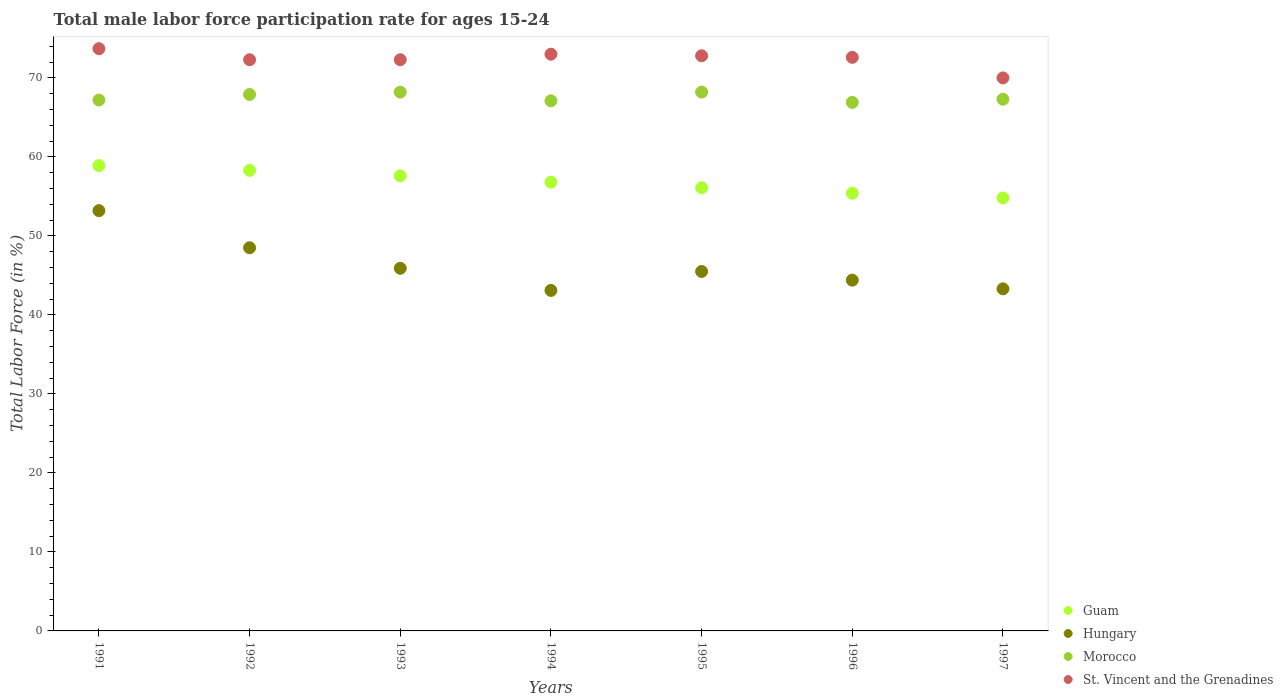How many different coloured dotlines are there?
Your answer should be very brief. 4. Is the number of dotlines equal to the number of legend labels?
Your response must be concise. Yes. What is the male labor force participation rate in St. Vincent and the Grenadines in 1994?
Give a very brief answer. 73. Across all years, what is the maximum male labor force participation rate in St. Vincent and the Grenadines?
Your answer should be compact. 73.7. Across all years, what is the minimum male labor force participation rate in Guam?
Ensure brevity in your answer.  54.8. In which year was the male labor force participation rate in Morocco maximum?
Keep it short and to the point. 1993. In which year was the male labor force participation rate in Morocco minimum?
Your answer should be very brief. 1996. What is the total male labor force participation rate in St. Vincent and the Grenadines in the graph?
Give a very brief answer. 506.7. What is the difference between the male labor force participation rate in Hungary in 1995 and that in 1996?
Keep it short and to the point. 1.1. What is the difference between the male labor force participation rate in Morocco in 1992 and the male labor force participation rate in Guam in 1994?
Keep it short and to the point. 11.1. What is the average male labor force participation rate in Morocco per year?
Offer a terse response. 67.54. In the year 1993, what is the difference between the male labor force participation rate in Guam and male labor force participation rate in St. Vincent and the Grenadines?
Keep it short and to the point. -14.7. What is the ratio of the male labor force participation rate in Morocco in 1992 to that in 1993?
Offer a very short reply. 1. Is the male labor force participation rate in Hungary in 1993 less than that in 1995?
Provide a short and direct response. No. Is the difference between the male labor force participation rate in Guam in 1993 and 1997 greater than the difference between the male labor force participation rate in St. Vincent and the Grenadines in 1993 and 1997?
Ensure brevity in your answer.  Yes. What is the difference between the highest and the second highest male labor force participation rate in Hungary?
Keep it short and to the point. 4.7. What is the difference between the highest and the lowest male labor force participation rate in Morocco?
Your answer should be very brief. 1.3. Is the sum of the male labor force participation rate in Hungary in 1995 and 1997 greater than the maximum male labor force participation rate in Guam across all years?
Offer a terse response. Yes. Is it the case that in every year, the sum of the male labor force participation rate in Guam and male labor force participation rate in St. Vincent and the Grenadines  is greater than the sum of male labor force participation rate in Hungary and male labor force participation rate in Morocco?
Keep it short and to the point. No. Is it the case that in every year, the sum of the male labor force participation rate in St. Vincent and the Grenadines and male labor force participation rate in Guam  is greater than the male labor force participation rate in Hungary?
Give a very brief answer. Yes. Is the male labor force participation rate in Guam strictly greater than the male labor force participation rate in Hungary over the years?
Your answer should be compact. Yes. Is the male labor force participation rate in Guam strictly less than the male labor force participation rate in Hungary over the years?
Ensure brevity in your answer.  No. How many dotlines are there?
Give a very brief answer. 4. How many years are there in the graph?
Ensure brevity in your answer.  7. Does the graph contain any zero values?
Provide a succinct answer. No. Does the graph contain grids?
Your answer should be very brief. No. Where does the legend appear in the graph?
Provide a short and direct response. Bottom right. How many legend labels are there?
Offer a very short reply. 4. What is the title of the graph?
Your answer should be compact. Total male labor force participation rate for ages 15-24. Does "Mauritius" appear as one of the legend labels in the graph?
Your answer should be very brief. No. What is the label or title of the Y-axis?
Keep it short and to the point. Total Labor Force (in %). What is the Total Labor Force (in %) of Guam in 1991?
Your response must be concise. 58.9. What is the Total Labor Force (in %) of Hungary in 1991?
Give a very brief answer. 53.2. What is the Total Labor Force (in %) of Morocco in 1991?
Ensure brevity in your answer.  67.2. What is the Total Labor Force (in %) of St. Vincent and the Grenadines in 1991?
Your response must be concise. 73.7. What is the Total Labor Force (in %) of Guam in 1992?
Your response must be concise. 58.3. What is the Total Labor Force (in %) in Hungary in 1992?
Provide a short and direct response. 48.5. What is the Total Labor Force (in %) of Morocco in 1992?
Provide a short and direct response. 67.9. What is the Total Labor Force (in %) in St. Vincent and the Grenadines in 1992?
Your response must be concise. 72.3. What is the Total Labor Force (in %) in Guam in 1993?
Keep it short and to the point. 57.6. What is the Total Labor Force (in %) in Hungary in 1993?
Your response must be concise. 45.9. What is the Total Labor Force (in %) in Morocco in 1993?
Your answer should be compact. 68.2. What is the Total Labor Force (in %) of St. Vincent and the Grenadines in 1993?
Provide a short and direct response. 72.3. What is the Total Labor Force (in %) in Guam in 1994?
Make the answer very short. 56.8. What is the Total Labor Force (in %) of Hungary in 1994?
Keep it short and to the point. 43.1. What is the Total Labor Force (in %) in Morocco in 1994?
Your response must be concise. 67.1. What is the Total Labor Force (in %) in St. Vincent and the Grenadines in 1994?
Offer a very short reply. 73. What is the Total Labor Force (in %) of Guam in 1995?
Your answer should be very brief. 56.1. What is the Total Labor Force (in %) of Hungary in 1995?
Your answer should be compact. 45.5. What is the Total Labor Force (in %) in Morocco in 1995?
Keep it short and to the point. 68.2. What is the Total Labor Force (in %) of St. Vincent and the Grenadines in 1995?
Give a very brief answer. 72.8. What is the Total Labor Force (in %) in Guam in 1996?
Keep it short and to the point. 55.4. What is the Total Labor Force (in %) in Hungary in 1996?
Your answer should be very brief. 44.4. What is the Total Labor Force (in %) in Morocco in 1996?
Keep it short and to the point. 66.9. What is the Total Labor Force (in %) of St. Vincent and the Grenadines in 1996?
Your response must be concise. 72.6. What is the Total Labor Force (in %) of Guam in 1997?
Offer a very short reply. 54.8. What is the Total Labor Force (in %) in Hungary in 1997?
Provide a short and direct response. 43.3. What is the Total Labor Force (in %) in Morocco in 1997?
Your answer should be compact. 67.3. What is the Total Labor Force (in %) of St. Vincent and the Grenadines in 1997?
Offer a terse response. 70. Across all years, what is the maximum Total Labor Force (in %) in Guam?
Your answer should be very brief. 58.9. Across all years, what is the maximum Total Labor Force (in %) in Hungary?
Your response must be concise. 53.2. Across all years, what is the maximum Total Labor Force (in %) in Morocco?
Ensure brevity in your answer.  68.2. Across all years, what is the maximum Total Labor Force (in %) in St. Vincent and the Grenadines?
Offer a very short reply. 73.7. Across all years, what is the minimum Total Labor Force (in %) in Guam?
Your answer should be compact. 54.8. Across all years, what is the minimum Total Labor Force (in %) in Hungary?
Offer a very short reply. 43.1. Across all years, what is the minimum Total Labor Force (in %) of Morocco?
Keep it short and to the point. 66.9. What is the total Total Labor Force (in %) in Guam in the graph?
Your answer should be compact. 397.9. What is the total Total Labor Force (in %) of Hungary in the graph?
Your answer should be compact. 323.9. What is the total Total Labor Force (in %) of Morocco in the graph?
Keep it short and to the point. 472.8. What is the total Total Labor Force (in %) in St. Vincent and the Grenadines in the graph?
Offer a terse response. 506.7. What is the difference between the Total Labor Force (in %) of Morocco in 1991 and that in 1992?
Provide a succinct answer. -0.7. What is the difference between the Total Labor Force (in %) in St. Vincent and the Grenadines in 1991 and that in 1992?
Provide a succinct answer. 1.4. What is the difference between the Total Labor Force (in %) of Hungary in 1991 and that in 1993?
Ensure brevity in your answer.  7.3. What is the difference between the Total Labor Force (in %) in St. Vincent and the Grenadines in 1991 and that in 1993?
Offer a very short reply. 1.4. What is the difference between the Total Labor Force (in %) of Guam in 1991 and that in 1994?
Offer a terse response. 2.1. What is the difference between the Total Labor Force (in %) of St. Vincent and the Grenadines in 1991 and that in 1994?
Keep it short and to the point. 0.7. What is the difference between the Total Labor Force (in %) in Guam in 1991 and that in 1995?
Offer a terse response. 2.8. What is the difference between the Total Labor Force (in %) in Hungary in 1991 and that in 1995?
Give a very brief answer. 7.7. What is the difference between the Total Labor Force (in %) of Morocco in 1991 and that in 1995?
Ensure brevity in your answer.  -1. What is the difference between the Total Labor Force (in %) of Guam in 1991 and that in 1996?
Provide a short and direct response. 3.5. What is the difference between the Total Labor Force (in %) in Guam in 1991 and that in 1997?
Give a very brief answer. 4.1. What is the difference between the Total Labor Force (in %) in Morocco in 1991 and that in 1997?
Your response must be concise. -0.1. What is the difference between the Total Labor Force (in %) in St. Vincent and the Grenadines in 1991 and that in 1997?
Provide a succinct answer. 3.7. What is the difference between the Total Labor Force (in %) of Guam in 1992 and that in 1993?
Offer a very short reply. 0.7. What is the difference between the Total Labor Force (in %) of Guam in 1992 and that in 1994?
Offer a very short reply. 1.5. What is the difference between the Total Labor Force (in %) of Hungary in 1992 and that in 1994?
Your response must be concise. 5.4. What is the difference between the Total Labor Force (in %) of St. Vincent and the Grenadines in 1992 and that in 1994?
Provide a succinct answer. -0.7. What is the difference between the Total Labor Force (in %) in Guam in 1992 and that in 1995?
Provide a short and direct response. 2.2. What is the difference between the Total Labor Force (in %) of Morocco in 1992 and that in 1995?
Your response must be concise. -0.3. What is the difference between the Total Labor Force (in %) of St. Vincent and the Grenadines in 1992 and that in 1995?
Make the answer very short. -0.5. What is the difference between the Total Labor Force (in %) in Hungary in 1992 and that in 1996?
Your answer should be very brief. 4.1. What is the difference between the Total Labor Force (in %) of St. Vincent and the Grenadines in 1992 and that in 1996?
Offer a very short reply. -0.3. What is the difference between the Total Labor Force (in %) in Morocco in 1992 and that in 1997?
Your answer should be compact. 0.6. What is the difference between the Total Labor Force (in %) of Hungary in 1993 and that in 1995?
Your answer should be compact. 0.4. What is the difference between the Total Labor Force (in %) of Morocco in 1993 and that in 1995?
Ensure brevity in your answer.  0. What is the difference between the Total Labor Force (in %) of St. Vincent and the Grenadines in 1993 and that in 1995?
Provide a short and direct response. -0.5. What is the difference between the Total Labor Force (in %) in Morocco in 1993 and that in 1996?
Provide a short and direct response. 1.3. What is the difference between the Total Labor Force (in %) in St. Vincent and the Grenadines in 1993 and that in 1996?
Provide a succinct answer. -0.3. What is the difference between the Total Labor Force (in %) of Guam in 1993 and that in 1997?
Your answer should be compact. 2.8. What is the difference between the Total Labor Force (in %) in Morocco in 1993 and that in 1997?
Offer a terse response. 0.9. What is the difference between the Total Labor Force (in %) of St. Vincent and the Grenadines in 1993 and that in 1997?
Make the answer very short. 2.3. What is the difference between the Total Labor Force (in %) of Guam in 1994 and that in 1995?
Offer a very short reply. 0.7. What is the difference between the Total Labor Force (in %) in Hungary in 1994 and that in 1995?
Offer a very short reply. -2.4. What is the difference between the Total Labor Force (in %) in Morocco in 1994 and that in 1995?
Give a very brief answer. -1.1. What is the difference between the Total Labor Force (in %) in St. Vincent and the Grenadines in 1994 and that in 1995?
Offer a terse response. 0.2. What is the difference between the Total Labor Force (in %) of Morocco in 1994 and that in 1996?
Your response must be concise. 0.2. What is the difference between the Total Labor Force (in %) in St. Vincent and the Grenadines in 1994 and that in 1996?
Ensure brevity in your answer.  0.4. What is the difference between the Total Labor Force (in %) in Hungary in 1994 and that in 1997?
Your response must be concise. -0.2. What is the difference between the Total Labor Force (in %) in Guam in 1995 and that in 1997?
Your response must be concise. 1.3. What is the difference between the Total Labor Force (in %) in Hungary in 1995 and that in 1997?
Your response must be concise. 2.2. What is the difference between the Total Labor Force (in %) in Guam in 1996 and that in 1997?
Provide a succinct answer. 0.6. What is the difference between the Total Labor Force (in %) of Guam in 1991 and the Total Labor Force (in %) of St. Vincent and the Grenadines in 1992?
Provide a short and direct response. -13.4. What is the difference between the Total Labor Force (in %) of Hungary in 1991 and the Total Labor Force (in %) of Morocco in 1992?
Offer a very short reply. -14.7. What is the difference between the Total Labor Force (in %) in Hungary in 1991 and the Total Labor Force (in %) in St. Vincent and the Grenadines in 1992?
Your answer should be compact. -19.1. What is the difference between the Total Labor Force (in %) in Morocco in 1991 and the Total Labor Force (in %) in St. Vincent and the Grenadines in 1992?
Keep it short and to the point. -5.1. What is the difference between the Total Labor Force (in %) in Guam in 1991 and the Total Labor Force (in %) in Hungary in 1993?
Provide a succinct answer. 13. What is the difference between the Total Labor Force (in %) of Hungary in 1991 and the Total Labor Force (in %) of Morocco in 1993?
Give a very brief answer. -15. What is the difference between the Total Labor Force (in %) in Hungary in 1991 and the Total Labor Force (in %) in St. Vincent and the Grenadines in 1993?
Offer a very short reply. -19.1. What is the difference between the Total Labor Force (in %) of Guam in 1991 and the Total Labor Force (in %) of Hungary in 1994?
Offer a terse response. 15.8. What is the difference between the Total Labor Force (in %) in Guam in 1991 and the Total Labor Force (in %) in St. Vincent and the Grenadines in 1994?
Your answer should be compact. -14.1. What is the difference between the Total Labor Force (in %) of Hungary in 1991 and the Total Labor Force (in %) of St. Vincent and the Grenadines in 1994?
Make the answer very short. -19.8. What is the difference between the Total Labor Force (in %) in Guam in 1991 and the Total Labor Force (in %) in Hungary in 1995?
Your answer should be compact. 13.4. What is the difference between the Total Labor Force (in %) of Hungary in 1991 and the Total Labor Force (in %) of Morocco in 1995?
Provide a short and direct response. -15. What is the difference between the Total Labor Force (in %) in Hungary in 1991 and the Total Labor Force (in %) in St. Vincent and the Grenadines in 1995?
Your answer should be compact. -19.6. What is the difference between the Total Labor Force (in %) in Guam in 1991 and the Total Labor Force (in %) in Hungary in 1996?
Your answer should be very brief. 14.5. What is the difference between the Total Labor Force (in %) in Guam in 1991 and the Total Labor Force (in %) in St. Vincent and the Grenadines in 1996?
Ensure brevity in your answer.  -13.7. What is the difference between the Total Labor Force (in %) in Hungary in 1991 and the Total Labor Force (in %) in Morocco in 1996?
Give a very brief answer. -13.7. What is the difference between the Total Labor Force (in %) in Hungary in 1991 and the Total Labor Force (in %) in St. Vincent and the Grenadines in 1996?
Your response must be concise. -19.4. What is the difference between the Total Labor Force (in %) of Hungary in 1991 and the Total Labor Force (in %) of Morocco in 1997?
Offer a very short reply. -14.1. What is the difference between the Total Labor Force (in %) of Hungary in 1991 and the Total Labor Force (in %) of St. Vincent and the Grenadines in 1997?
Provide a short and direct response. -16.8. What is the difference between the Total Labor Force (in %) of Morocco in 1991 and the Total Labor Force (in %) of St. Vincent and the Grenadines in 1997?
Keep it short and to the point. -2.8. What is the difference between the Total Labor Force (in %) in Guam in 1992 and the Total Labor Force (in %) in Hungary in 1993?
Give a very brief answer. 12.4. What is the difference between the Total Labor Force (in %) of Guam in 1992 and the Total Labor Force (in %) of Morocco in 1993?
Your answer should be compact. -9.9. What is the difference between the Total Labor Force (in %) of Guam in 1992 and the Total Labor Force (in %) of St. Vincent and the Grenadines in 1993?
Provide a short and direct response. -14. What is the difference between the Total Labor Force (in %) of Hungary in 1992 and the Total Labor Force (in %) of Morocco in 1993?
Keep it short and to the point. -19.7. What is the difference between the Total Labor Force (in %) in Hungary in 1992 and the Total Labor Force (in %) in St. Vincent and the Grenadines in 1993?
Offer a terse response. -23.8. What is the difference between the Total Labor Force (in %) of Guam in 1992 and the Total Labor Force (in %) of Morocco in 1994?
Offer a very short reply. -8.8. What is the difference between the Total Labor Force (in %) of Guam in 1992 and the Total Labor Force (in %) of St. Vincent and the Grenadines in 1994?
Offer a terse response. -14.7. What is the difference between the Total Labor Force (in %) in Hungary in 1992 and the Total Labor Force (in %) in Morocco in 1994?
Give a very brief answer. -18.6. What is the difference between the Total Labor Force (in %) of Hungary in 1992 and the Total Labor Force (in %) of St. Vincent and the Grenadines in 1994?
Your answer should be compact. -24.5. What is the difference between the Total Labor Force (in %) in Morocco in 1992 and the Total Labor Force (in %) in St. Vincent and the Grenadines in 1994?
Your answer should be very brief. -5.1. What is the difference between the Total Labor Force (in %) of Guam in 1992 and the Total Labor Force (in %) of Hungary in 1995?
Offer a terse response. 12.8. What is the difference between the Total Labor Force (in %) in Guam in 1992 and the Total Labor Force (in %) in Morocco in 1995?
Offer a very short reply. -9.9. What is the difference between the Total Labor Force (in %) in Hungary in 1992 and the Total Labor Force (in %) in Morocco in 1995?
Make the answer very short. -19.7. What is the difference between the Total Labor Force (in %) in Hungary in 1992 and the Total Labor Force (in %) in St. Vincent and the Grenadines in 1995?
Provide a short and direct response. -24.3. What is the difference between the Total Labor Force (in %) of Guam in 1992 and the Total Labor Force (in %) of Morocco in 1996?
Offer a terse response. -8.6. What is the difference between the Total Labor Force (in %) in Guam in 1992 and the Total Labor Force (in %) in St. Vincent and the Grenadines in 1996?
Ensure brevity in your answer.  -14.3. What is the difference between the Total Labor Force (in %) in Hungary in 1992 and the Total Labor Force (in %) in Morocco in 1996?
Offer a terse response. -18.4. What is the difference between the Total Labor Force (in %) of Hungary in 1992 and the Total Labor Force (in %) of St. Vincent and the Grenadines in 1996?
Your response must be concise. -24.1. What is the difference between the Total Labor Force (in %) in Morocco in 1992 and the Total Labor Force (in %) in St. Vincent and the Grenadines in 1996?
Your response must be concise. -4.7. What is the difference between the Total Labor Force (in %) in Hungary in 1992 and the Total Labor Force (in %) in Morocco in 1997?
Provide a succinct answer. -18.8. What is the difference between the Total Labor Force (in %) in Hungary in 1992 and the Total Labor Force (in %) in St. Vincent and the Grenadines in 1997?
Provide a short and direct response. -21.5. What is the difference between the Total Labor Force (in %) in Morocco in 1992 and the Total Labor Force (in %) in St. Vincent and the Grenadines in 1997?
Your answer should be compact. -2.1. What is the difference between the Total Labor Force (in %) in Guam in 1993 and the Total Labor Force (in %) in St. Vincent and the Grenadines in 1994?
Make the answer very short. -15.4. What is the difference between the Total Labor Force (in %) in Hungary in 1993 and the Total Labor Force (in %) in Morocco in 1994?
Give a very brief answer. -21.2. What is the difference between the Total Labor Force (in %) of Hungary in 1993 and the Total Labor Force (in %) of St. Vincent and the Grenadines in 1994?
Offer a terse response. -27.1. What is the difference between the Total Labor Force (in %) of Morocco in 1993 and the Total Labor Force (in %) of St. Vincent and the Grenadines in 1994?
Provide a succinct answer. -4.8. What is the difference between the Total Labor Force (in %) of Guam in 1993 and the Total Labor Force (in %) of Hungary in 1995?
Make the answer very short. 12.1. What is the difference between the Total Labor Force (in %) of Guam in 1993 and the Total Labor Force (in %) of Morocco in 1995?
Offer a very short reply. -10.6. What is the difference between the Total Labor Force (in %) in Guam in 1993 and the Total Labor Force (in %) in St. Vincent and the Grenadines in 1995?
Make the answer very short. -15.2. What is the difference between the Total Labor Force (in %) in Hungary in 1993 and the Total Labor Force (in %) in Morocco in 1995?
Offer a very short reply. -22.3. What is the difference between the Total Labor Force (in %) of Hungary in 1993 and the Total Labor Force (in %) of St. Vincent and the Grenadines in 1995?
Keep it short and to the point. -26.9. What is the difference between the Total Labor Force (in %) of Guam in 1993 and the Total Labor Force (in %) of Hungary in 1996?
Ensure brevity in your answer.  13.2. What is the difference between the Total Labor Force (in %) in Guam in 1993 and the Total Labor Force (in %) in Morocco in 1996?
Keep it short and to the point. -9.3. What is the difference between the Total Labor Force (in %) of Hungary in 1993 and the Total Labor Force (in %) of St. Vincent and the Grenadines in 1996?
Give a very brief answer. -26.7. What is the difference between the Total Labor Force (in %) of Morocco in 1993 and the Total Labor Force (in %) of St. Vincent and the Grenadines in 1996?
Give a very brief answer. -4.4. What is the difference between the Total Labor Force (in %) of Guam in 1993 and the Total Labor Force (in %) of Hungary in 1997?
Make the answer very short. 14.3. What is the difference between the Total Labor Force (in %) of Guam in 1993 and the Total Labor Force (in %) of Morocco in 1997?
Keep it short and to the point. -9.7. What is the difference between the Total Labor Force (in %) of Hungary in 1993 and the Total Labor Force (in %) of Morocco in 1997?
Give a very brief answer. -21.4. What is the difference between the Total Labor Force (in %) in Hungary in 1993 and the Total Labor Force (in %) in St. Vincent and the Grenadines in 1997?
Keep it short and to the point. -24.1. What is the difference between the Total Labor Force (in %) in Morocco in 1993 and the Total Labor Force (in %) in St. Vincent and the Grenadines in 1997?
Make the answer very short. -1.8. What is the difference between the Total Labor Force (in %) in Hungary in 1994 and the Total Labor Force (in %) in Morocco in 1995?
Keep it short and to the point. -25.1. What is the difference between the Total Labor Force (in %) in Hungary in 1994 and the Total Labor Force (in %) in St. Vincent and the Grenadines in 1995?
Your answer should be very brief. -29.7. What is the difference between the Total Labor Force (in %) in Guam in 1994 and the Total Labor Force (in %) in Hungary in 1996?
Make the answer very short. 12.4. What is the difference between the Total Labor Force (in %) in Guam in 1994 and the Total Labor Force (in %) in Morocco in 1996?
Provide a short and direct response. -10.1. What is the difference between the Total Labor Force (in %) of Guam in 1994 and the Total Labor Force (in %) of St. Vincent and the Grenadines in 1996?
Provide a short and direct response. -15.8. What is the difference between the Total Labor Force (in %) in Hungary in 1994 and the Total Labor Force (in %) in Morocco in 1996?
Offer a terse response. -23.8. What is the difference between the Total Labor Force (in %) of Hungary in 1994 and the Total Labor Force (in %) of St. Vincent and the Grenadines in 1996?
Provide a succinct answer. -29.5. What is the difference between the Total Labor Force (in %) of Guam in 1994 and the Total Labor Force (in %) of Hungary in 1997?
Offer a very short reply. 13.5. What is the difference between the Total Labor Force (in %) in Hungary in 1994 and the Total Labor Force (in %) in Morocco in 1997?
Your answer should be compact. -24.2. What is the difference between the Total Labor Force (in %) in Hungary in 1994 and the Total Labor Force (in %) in St. Vincent and the Grenadines in 1997?
Your response must be concise. -26.9. What is the difference between the Total Labor Force (in %) in Morocco in 1994 and the Total Labor Force (in %) in St. Vincent and the Grenadines in 1997?
Ensure brevity in your answer.  -2.9. What is the difference between the Total Labor Force (in %) of Guam in 1995 and the Total Labor Force (in %) of Hungary in 1996?
Your answer should be very brief. 11.7. What is the difference between the Total Labor Force (in %) of Guam in 1995 and the Total Labor Force (in %) of Morocco in 1996?
Give a very brief answer. -10.8. What is the difference between the Total Labor Force (in %) of Guam in 1995 and the Total Labor Force (in %) of St. Vincent and the Grenadines in 1996?
Give a very brief answer. -16.5. What is the difference between the Total Labor Force (in %) in Hungary in 1995 and the Total Labor Force (in %) in Morocco in 1996?
Your answer should be very brief. -21.4. What is the difference between the Total Labor Force (in %) in Hungary in 1995 and the Total Labor Force (in %) in St. Vincent and the Grenadines in 1996?
Ensure brevity in your answer.  -27.1. What is the difference between the Total Labor Force (in %) of Guam in 1995 and the Total Labor Force (in %) of Hungary in 1997?
Make the answer very short. 12.8. What is the difference between the Total Labor Force (in %) of Guam in 1995 and the Total Labor Force (in %) of St. Vincent and the Grenadines in 1997?
Your response must be concise. -13.9. What is the difference between the Total Labor Force (in %) of Hungary in 1995 and the Total Labor Force (in %) of Morocco in 1997?
Keep it short and to the point. -21.8. What is the difference between the Total Labor Force (in %) in Hungary in 1995 and the Total Labor Force (in %) in St. Vincent and the Grenadines in 1997?
Your answer should be very brief. -24.5. What is the difference between the Total Labor Force (in %) of Guam in 1996 and the Total Labor Force (in %) of Hungary in 1997?
Offer a terse response. 12.1. What is the difference between the Total Labor Force (in %) in Guam in 1996 and the Total Labor Force (in %) in Morocco in 1997?
Your response must be concise. -11.9. What is the difference between the Total Labor Force (in %) in Guam in 1996 and the Total Labor Force (in %) in St. Vincent and the Grenadines in 1997?
Provide a short and direct response. -14.6. What is the difference between the Total Labor Force (in %) in Hungary in 1996 and the Total Labor Force (in %) in Morocco in 1997?
Provide a succinct answer. -22.9. What is the difference between the Total Labor Force (in %) in Hungary in 1996 and the Total Labor Force (in %) in St. Vincent and the Grenadines in 1997?
Your answer should be compact. -25.6. What is the difference between the Total Labor Force (in %) of Morocco in 1996 and the Total Labor Force (in %) of St. Vincent and the Grenadines in 1997?
Provide a succinct answer. -3.1. What is the average Total Labor Force (in %) in Guam per year?
Make the answer very short. 56.84. What is the average Total Labor Force (in %) in Hungary per year?
Offer a very short reply. 46.27. What is the average Total Labor Force (in %) in Morocco per year?
Provide a succinct answer. 67.54. What is the average Total Labor Force (in %) in St. Vincent and the Grenadines per year?
Keep it short and to the point. 72.39. In the year 1991, what is the difference between the Total Labor Force (in %) of Guam and Total Labor Force (in %) of Hungary?
Keep it short and to the point. 5.7. In the year 1991, what is the difference between the Total Labor Force (in %) of Guam and Total Labor Force (in %) of Morocco?
Your response must be concise. -8.3. In the year 1991, what is the difference between the Total Labor Force (in %) in Guam and Total Labor Force (in %) in St. Vincent and the Grenadines?
Provide a short and direct response. -14.8. In the year 1991, what is the difference between the Total Labor Force (in %) of Hungary and Total Labor Force (in %) of St. Vincent and the Grenadines?
Ensure brevity in your answer.  -20.5. In the year 1991, what is the difference between the Total Labor Force (in %) of Morocco and Total Labor Force (in %) of St. Vincent and the Grenadines?
Your answer should be compact. -6.5. In the year 1992, what is the difference between the Total Labor Force (in %) of Guam and Total Labor Force (in %) of St. Vincent and the Grenadines?
Make the answer very short. -14. In the year 1992, what is the difference between the Total Labor Force (in %) of Hungary and Total Labor Force (in %) of Morocco?
Your response must be concise. -19.4. In the year 1992, what is the difference between the Total Labor Force (in %) in Hungary and Total Labor Force (in %) in St. Vincent and the Grenadines?
Give a very brief answer. -23.8. In the year 1993, what is the difference between the Total Labor Force (in %) of Guam and Total Labor Force (in %) of Hungary?
Offer a very short reply. 11.7. In the year 1993, what is the difference between the Total Labor Force (in %) of Guam and Total Labor Force (in %) of St. Vincent and the Grenadines?
Offer a very short reply. -14.7. In the year 1993, what is the difference between the Total Labor Force (in %) of Hungary and Total Labor Force (in %) of Morocco?
Offer a very short reply. -22.3. In the year 1993, what is the difference between the Total Labor Force (in %) of Hungary and Total Labor Force (in %) of St. Vincent and the Grenadines?
Provide a succinct answer. -26.4. In the year 1993, what is the difference between the Total Labor Force (in %) in Morocco and Total Labor Force (in %) in St. Vincent and the Grenadines?
Provide a short and direct response. -4.1. In the year 1994, what is the difference between the Total Labor Force (in %) of Guam and Total Labor Force (in %) of Hungary?
Your response must be concise. 13.7. In the year 1994, what is the difference between the Total Labor Force (in %) in Guam and Total Labor Force (in %) in Morocco?
Your response must be concise. -10.3. In the year 1994, what is the difference between the Total Labor Force (in %) in Guam and Total Labor Force (in %) in St. Vincent and the Grenadines?
Provide a succinct answer. -16.2. In the year 1994, what is the difference between the Total Labor Force (in %) of Hungary and Total Labor Force (in %) of St. Vincent and the Grenadines?
Make the answer very short. -29.9. In the year 1995, what is the difference between the Total Labor Force (in %) of Guam and Total Labor Force (in %) of Morocco?
Offer a terse response. -12.1. In the year 1995, what is the difference between the Total Labor Force (in %) in Guam and Total Labor Force (in %) in St. Vincent and the Grenadines?
Make the answer very short. -16.7. In the year 1995, what is the difference between the Total Labor Force (in %) in Hungary and Total Labor Force (in %) in Morocco?
Provide a short and direct response. -22.7. In the year 1995, what is the difference between the Total Labor Force (in %) of Hungary and Total Labor Force (in %) of St. Vincent and the Grenadines?
Provide a short and direct response. -27.3. In the year 1995, what is the difference between the Total Labor Force (in %) in Morocco and Total Labor Force (in %) in St. Vincent and the Grenadines?
Your response must be concise. -4.6. In the year 1996, what is the difference between the Total Labor Force (in %) in Guam and Total Labor Force (in %) in Hungary?
Keep it short and to the point. 11. In the year 1996, what is the difference between the Total Labor Force (in %) of Guam and Total Labor Force (in %) of St. Vincent and the Grenadines?
Provide a succinct answer. -17.2. In the year 1996, what is the difference between the Total Labor Force (in %) of Hungary and Total Labor Force (in %) of Morocco?
Offer a terse response. -22.5. In the year 1996, what is the difference between the Total Labor Force (in %) of Hungary and Total Labor Force (in %) of St. Vincent and the Grenadines?
Offer a very short reply. -28.2. In the year 1997, what is the difference between the Total Labor Force (in %) of Guam and Total Labor Force (in %) of Morocco?
Offer a terse response. -12.5. In the year 1997, what is the difference between the Total Labor Force (in %) of Guam and Total Labor Force (in %) of St. Vincent and the Grenadines?
Keep it short and to the point. -15.2. In the year 1997, what is the difference between the Total Labor Force (in %) in Hungary and Total Labor Force (in %) in St. Vincent and the Grenadines?
Your answer should be very brief. -26.7. In the year 1997, what is the difference between the Total Labor Force (in %) in Morocco and Total Labor Force (in %) in St. Vincent and the Grenadines?
Give a very brief answer. -2.7. What is the ratio of the Total Labor Force (in %) of Guam in 1991 to that in 1992?
Ensure brevity in your answer.  1.01. What is the ratio of the Total Labor Force (in %) of Hungary in 1991 to that in 1992?
Keep it short and to the point. 1.1. What is the ratio of the Total Labor Force (in %) in Morocco in 1991 to that in 1992?
Your answer should be very brief. 0.99. What is the ratio of the Total Labor Force (in %) in St. Vincent and the Grenadines in 1991 to that in 1992?
Provide a short and direct response. 1.02. What is the ratio of the Total Labor Force (in %) of Guam in 1991 to that in 1993?
Your response must be concise. 1.02. What is the ratio of the Total Labor Force (in %) of Hungary in 1991 to that in 1993?
Your answer should be compact. 1.16. What is the ratio of the Total Labor Force (in %) in St. Vincent and the Grenadines in 1991 to that in 1993?
Offer a terse response. 1.02. What is the ratio of the Total Labor Force (in %) in Guam in 1991 to that in 1994?
Offer a terse response. 1.04. What is the ratio of the Total Labor Force (in %) of Hungary in 1991 to that in 1994?
Offer a terse response. 1.23. What is the ratio of the Total Labor Force (in %) in Morocco in 1991 to that in 1994?
Ensure brevity in your answer.  1. What is the ratio of the Total Labor Force (in %) in St. Vincent and the Grenadines in 1991 to that in 1994?
Make the answer very short. 1.01. What is the ratio of the Total Labor Force (in %) of Guam in 1991 to that in 1995?
Give a very brief answer. 1.05. What is the ratio of the Total Labor Force (in %) in Hungary in 1991 to that in 1995?
Your answer should be compact. 1.17. What is the ratio of the Total Labor Force (in %) in St. Vincent and the Grenadines in 1991 to that in 1995?
Make the answer very short. 1.01. What is the ratio of the Total Labor Force (in %) in Guam in 1991 to that in 1996?
Provide a succinct answer. 1.06. What is the ratio of the Total Labor Force (in %) in Hungary in 1991 to that in 1996?
Give a very brief answer. 1.2. What is the ratio of the Total Labor Force (in %) in St. Vincent and the Grenadines in 1991 to that in 1996?
Offer a very short reply. 1.02. What is the ratio of the Total Labor Force (in %) of Guam in 1991 to that in 1997?
Your answer should be compact. 1.07. What is the ratio of the Total Labor Force (in %) of Hungary in 1991 to that in 1997?
Give a very brief answer. 1.23. What is the ratio of the Total Labor Force (in %) in St. Vincent and the Grenadines in 1991 to that in 1997?
Your response must be concise. 1.05. What is the ratio of the Total Labor Force (in %) of Guam in 1992 to that in 1993?
Offer a very short reply. 1.01. What is the ratio of the Total Labor Force (in %) of Hungary in 1992 to that in 1993?
Offer a terse response. 1.06. What is the ratio of the Total Labor Force (in %) of Guam in 1992 to that in 1994?
Provide a short and direct response. 1.03. What is the ratio of the Total Labor Force (in %) of Hungary in 1992 to that in 1994?
Offer a very short reply. 1.13. What is the ratio of the Total Labor Force (in %) in Morocco in 1992 to that in 1994?
Provide a succinct answer. 1.01. What is the ratio of the Total Labor Force (in %) of St. Vincent and the Grenadines in 1992 to that in 1994?
Keep it short and to the point. 0.99. What is the ratio of the Total Labor Force (in %) in Guam in 1992 to that in 1995?
Your answer should be very brief. 1.04. What is the ratio of the Total Labor Force (in %) of Hungary in 1992 to that in 1995?
Your response must be concise. 1.07. What is the ratio of the Total Labor Force (in %) in St. Vincent and the Grenadines in 1992 to that in 1995?
Provide a succinct answer. 0.99. What is the ratio of the Total Labor Force (in %) in Guam in 1992 to that in 1996?
Keep it short and to the point. 1.05. What is the ratio of the Total Labor Force (in %) of Hungary in 1992 to that in 1996?
Your answer should be compact. 1.09. What is the ratio of the Total Labor Force (in %) in Morocco in 1992 to that in 1996?
Provide a short and direct response. 1.01. What is the ratio of the Total Labor Force (in %) in Guam in 1992 to that in 1997?
Offer a very short reply. 1.06. What is the ratio of the Total Labor Force (in %) in Hungary in 1992 to that in 1997?
Provide a short and direct response. 1.12. What is the ratio of the Total Labor Force (in %) in Morocco in 1992 to that in 1997?
Provide a succinct answer. 1.01. What is the ratio of the Total Labor Force (in %) in St. Vincent and the Grenadines in 1992 to that in 1997?
Your answer should be very brief. 1.03. What is the ratio of the Total Labor Force (in %) of Guam in 1993 to that in 1994?
Make the answer very short. 1.01. What is the ratio of the Total Labor Force (in %) in Hungary in 1993 to that in 1994?
Ensure brevity in your answer.  1.06. What is the ratio of the Total Labor Force (in %) of Morocco in 1993 to that in 1994?
Your answer should be very brief. 1.02. What is the ratio of the Total Labor Force (in %) of St. Vincent and the Grenadines in 1993 to that in 1994?
Your answer should be compact. 0.99. What is the ratio of the Total Labor Force (in %) in Guam in 1993 to that in 1995?
Offer a terse response. 1.03. What is the ratio of the Total Labor Force (in %) of Hungary in 1993 to that in 1995?
Your answer should be compact. 1.01. What is the ratio of the Total Labor Force (in %) of Morocco in 1993 to that in 1995?
Your answer should be very brief. 1. What is the ratio of the Total Labor Force (in %) of St. Vincent and the Grenadines in 1993 to that in 1995?
Your response must be concise. 0.99. What is the ratio of the Total Labor Force (in %) of Guam in 1993 to that in 1996?
Your response must be concise. 1.04. What is the ratio of the Total Labor Force (in %) of Hungary in 1993 to that in 1996?
Provide a succinct answer. 1.03. What is the ratio of the Total Labor Force (in %) of Morocco in 1993 to that in 1996?
Your answer should be compact. 1.02. What is the ratio of the Total Labor Force (in %) of St. Vincent and the Grenadines in 1993 to that in 1996?
Provide a succinct answer. 1. What is the ratio of the Total Labor Force (in %) in Guam in 1993 to that in 1997?
Provide a succinct answer. 1.05. What is the ratio of the Total Labor Force (in %) in Hungary in 1993 to that in 1997?
Keep it short and to the point. 1.06. What is the ratio of the Total Labor Force (in %) in Morocco in 1993 to that in 1997?
Offer a very short reply. 1.01. What is the ratio of the Total Labor Force (in %) in St. Vincent and the Grenadines in 1993 to that in 1997?
Offer a very short reply. 1.03. What is the ratio of the Total Labor Force (in %) of Guam in 1994 to that in 1995?
Your response must be concise. 1.01. What is the ratio of the Total Labor Force (in %) in Hungary in 1994 to that in 1995?
Your response must be concise. 0.95. What is the ratio of the Total Labor Force (in %) of Morocco in 1994 to that in 1995?
Provide a succinct answer. 0.98. What is the ratio of the Total Labor Force (in %) of Guam in 1994 to that in 1996?
Provide a short and direct response. 1.03. What is the ratio of the Total Labor Force (in %) of Hungary in 1994 to that in 1996?
Give a very brief answer. 0.97. What is the ratio of the Total Labor Force (in %) of Morocco in 1994 to that in 1996?
Your answer should be compact. 1. What is the ratio of the Total Labor Force (in %) of Guam in 1994 to that in 1997?
Your answer should be compact. 1.04. What is the ratio of the Total Labor Force (in %) of St. Vincent and the Grenadines in 1994 to that in 1997?
Provide a succinct answer. 1.04. What is the ratio of the Total Labor Force (in %) in Guam in 1995 to that in 1996?
Your answer should be compact. 1.01. What is the ratio of the Total Labor Force (in %) in Hungary in 1995 to that in 1996?
Your answer should be compact. 1.02. What is the ratio of the Total Labor Force (in %) of Morocco in 1995 to that in 1996?
Your answer should be compact. 1.02. What is the ratio of the Total Labor Force (in %) in St. Vincent and the Grenadines in 1995 to that in 1996?
Ensure brevity in your answer.  1. What is the ratio of the Total Labor Force (in %) in Guam in 1995 to that in 1997?
Offer a very short reply. 1.02. What is the ratio of the Total Labor Force (in %) of Hungary in 1995 to that in 1997?
Your response must be concise. 1.05. What is the ratio of the Total Labor Force (in %) in Morocco in 1995 to that in 1997?
Ensure brevity in your answer.  1.01. What is the ratio of the Total Labor Force (in %) of St. Vincent and the Grenadines in 1995 to that in 1997?
Offer a very short reply. 1.04. What is the ratio of the Total Labor Force (in %) in Guam in 1996 to that in 1997?
Keep it short and to the point. 1.01. What is the ratio of the Total Labor Force (in %) in Hungary in 1996 to that in 1997?
Make the answer very short. 1.03. What is the ratio of the Total Labor Force (in %) of Morocco in 1996 to that in 1997?
Your response must be concise. 0.99. What is the ratio of the Total Labor Force (in %) in St. Vincent and the Grenadines in 1996 to that in 1997?
Your answer should be very brief. 1.04. What is the difference between the highest and the second highest Total Labor Force (in %) in Morocco?
Keep it short and to the point. 0. What is the difference between the highest and the lowest Total Labor Force (in %) in Guam?
Ensure brevity in your answer.  4.1. What is the difference between the highest and the lowest Total Labor Force (in %) in Hungary?
Keep it short and to the point. 10.1. What is the difference between the highest and the lowest Total Labor Force (in %) of Morocco?
Your answer should be very brief. 1.3. 